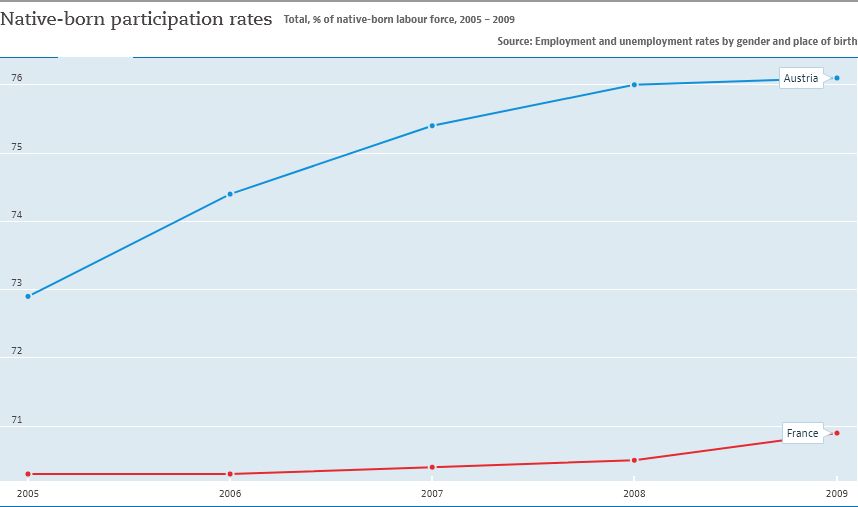Highlight a few significant elements in this photo. In 2005, the native-born participation rates in Austria reached the lowest levels on record. The graph compares Austria and France. 